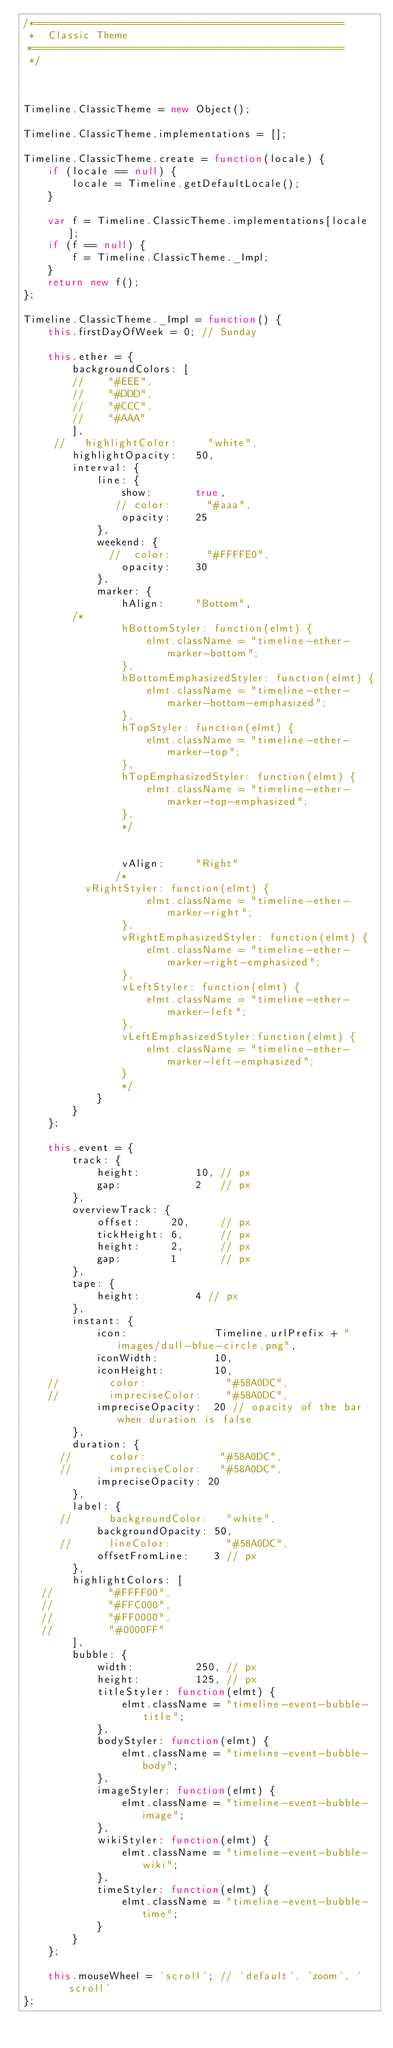<code> <loc_0><loc_0><loc_500><loc_500><_JavaScript_>/*==================================================
 *  Classic Theme
 *==================================================
 */



Timeline.ClassicTheme = new Object();

Timeline.ClassicTheme.implementations = [];

Timeline.ClassicTheme.create = function(locale) {
    if (locale == null) {
        locale = Timeline.getDefaultLocale();
    }
    
    var f = Timeline.ClassicTheme.implementations[locale];
    if (f == null) {
        f = Timeline.ClassicTheme._Impl;
    }
    return new f();
};

Timeline.ClassicTheme._Impl = function() {
    this.firstDayOfWeek = 0; // Sunday
	
    this.ether = {
        backgroundColors: [
        //    "#EEE",
        //    "#DDD",
        //    "#CCC",
        //    "#AAA"
        ],
     //   highlightColor:     "white",
        highlightOpacity:   50,
        interval: {
            line: {
                show:       true,
               // color:      "#aaa",
                opacity:    25
            },
            weekend: {
              //  color:      "#FFFFE0",
                opacity:    30
            },
            marker: {
                hAlign:     "Bottom",
				/*
                hBottomStyler: function(elmt) {
                    elmt.className = "timeline-ether-marker-bottom";
                },
                hBottomEmphasizedStyler: function(elmt) {
                    elmt.className = "timeline-ether-marker-bottom-emphasized";
                },
                hTopStyler: function(elmt) {
                    elmt.className = "timeline-ether-marker-top";
                },
                hTopEmphasizedStyler: function(elmt) {
                    elmt.className = "timeline-ether-marker-top-emphasized";
                },
                */
				
                    
                vAlign:     "Right"
               /*
			    vRightStyler: function(elmt) {
                    elmt.className = "timeline-ether-marker-right";
                },
                vRightEmphasizedStyler: function(elmt) {
                    elmt.className = "timeline-ether-marker-right-emphasized";
                },
                vLeftStyler: function(elmt) {
                    elmt.className = "timeline-ether-marker-left";
                },
                vLeftEmphasizedStyler:function(elmt) {
                    elmt.className = "timeline-ether-marker-left-emphasized";
                }
                */
            }
        }
    };
    
    this.event = {
        track: {
            height:         10, // px
            gap:            2   // px
        },
        overviewTrack: {
            offset:     20,     // px
            tickHeight: 6,      // px
            height:     2,      // px
            gap:        1       // px
        },
        tape: {
            height:         4 // px
        },
        instant: {
            icon:              Timeline.urlPrefix + "images/dull-blue-circle.png",
            iconWidth:         10,
            iconHeight:        10,
    //        color:             "#58A0DC",
    //        impreciseColor:    "#58A0DC",
            impreciseOpacity:  20 // opacity of the bar when duration is false
        },
        duration: {
      //      color:            "#58A0DC",
      //      impreciseColor:   "#58A0DC",
            impreciseOpacity: 20
        },
        label: {
      //      backgroundColor:   "white",
            backgroundOpacity: 50,
      //      lineColor:         "#58A0DC",
            offsetFromLine:    3 // px
        },
        highlightColors: [
   //         "#FFFF00",
   //         "#FFC000",
   //         "#FF0000",
   //         "#0000FF"
        ],
        bubble: {
            width:          250, // px
            height:         125, // px
            titleStyler: function(elmt) {
                elmt.className = "timeline-event-bubble-title";
            },
            bodyStyler: function(elmt) {
                elmt.className = "timeline-event-bubble-body";
            },
            imageStyler: function(elmt) {
                elmt.className = "timeline-event-bubble-image";
            },
            wikiStyler: function(elmt) {
                elmt.className = "timeline-event-bubble-wiki";
            },
            timeStyler: function(elmt) {
                elmt.className = "timeline-event-bubble-time";
            }
        }
    };
    
    this.mouseWheel = 'scroll'; // 'default', 'zoom', 'scroll'
};</code> 